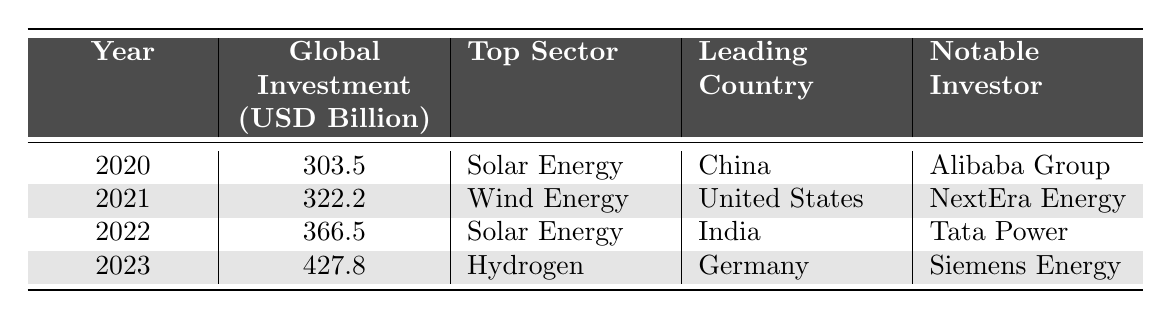What was the global investment in renewable energy in 2022? The table shows a specific value for the year 2022, which is listed as 366.5 billion USD.
Answer: 366.5 billion USD Which sector had the highest investment in 2021? From the table, the top sector listed for 2021 is Wind Energy.
Answer: Wind Energy Who was the notable investor in solar energy in 2020? According to the table, the notable investor for solar energy in 2020 was Alibaba Group.
Answer: Alibaba Group What was the increase in global investment from 2020 to 2023? The global investments for these years were 303.5 billion USD and 427.8 billion USD, respectively. The increase is 427.8 - 303.5 = 124.3 billion USD.
Answer: 124.3 billion USD Which country led in renewable energy investment in 2023? The table indicates that Germany was the leading country for the year 2023.
Answer: Germany Is it true that solar energy was the top sector in more than one year? By examining the table, solar energy appears as the top sector in both 2020 and 2022, hence it is true.
Answer: Yes What is the average global investment in renewable energy from 2020 to 2023? The total investment from 2020 to 2023 is 303.5 + 322.2 + 366.5 + 427.8 = 1419.0 billion USD. There are 4 data points, so the average is 1419.0 / 4 = 354.75 billion USD.
Answer: 354.75 billion USD Which notable investor is associated with hydrogen in 2023? The table specifies Siemens Energy as the notable investor for the hydrogen sector in 2023.
Answer: Siemens Energy In which year did India become the leading country for renewable energy investment? The table indicates that India was the leading country in the year 2022.
Answer: 2022 What was the trend in global investment from 2020 to 2023? By analyzing the values: 303.5 (2020) < 322.2 (2021) < 366.5 (2022) < 427.8 (2023), it shows increasing investment year-over-year.
Answer: Increasing 